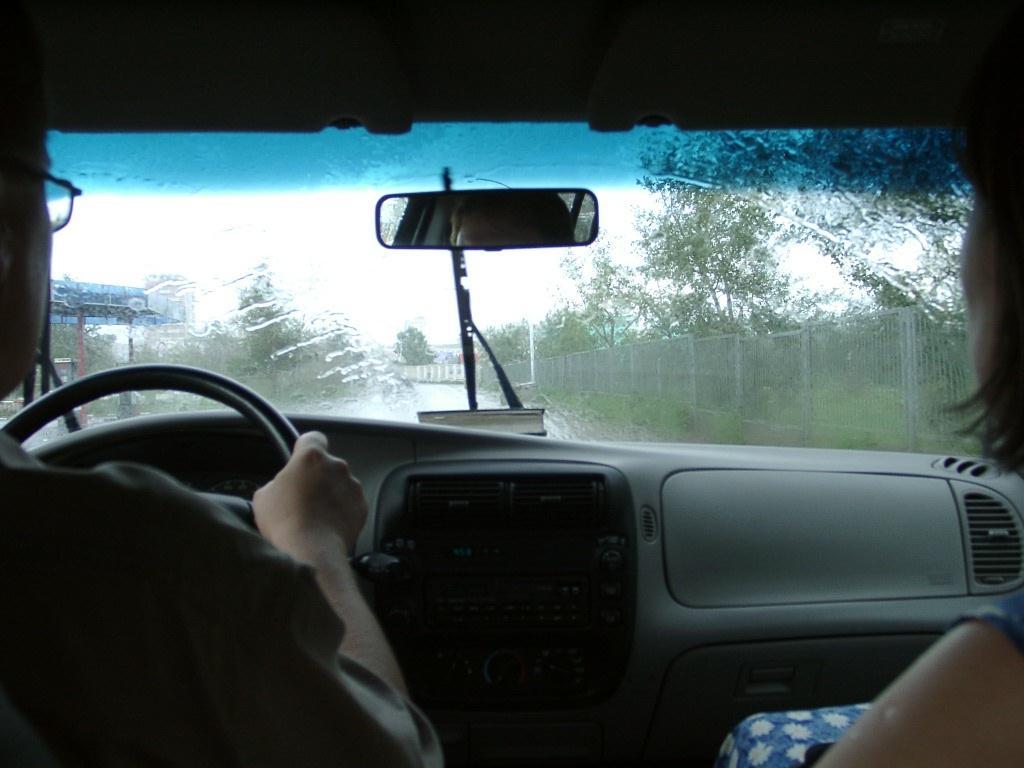Can you describe this image briefly? In this image there is a person holding the steering, beside the person there is a woman, in front of the person there is a dashboard, in front of the dashboard there is a book, in front of the book there is a wiper on the windshield, from the windshield we can see the road, beside the road there is a metal rod fence, on the other side of the fence there are trees. 